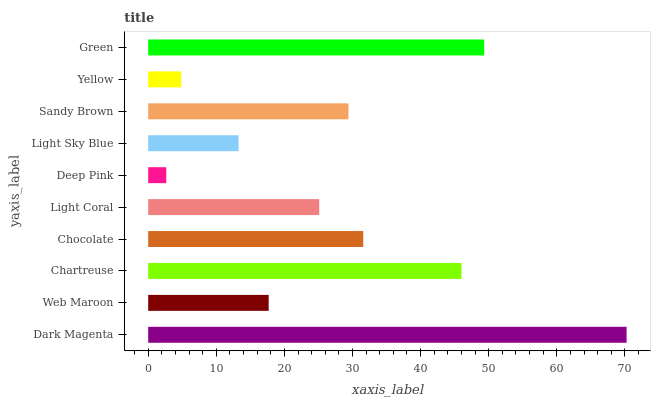Is Deep Pink the minimum?
Answer yes or no. Yes. Is Dark Magenta the maximum?
Answer yes or no. Yes. Is Web Maroon the minimum?
Answer yes or no. No. Is Web Maroon the maximum?
Answer yes or no. No. Is Dark Magenta greater than Web Maroon?
Answer yes or no. Yes. Is Web Maroon less than Dark Magenta?
Answer yes or no. Yes. Is Web Maroon greater than Dark Magenta?
Answer yes or no. No. Is Dark Magenta less than Web Maroon?
Answer yes or no. No. Is Sandy Brown the high median?
Answer yes or no. Yes. Is Light Coral the low median?
Answer yes or no. Yes. Is Light Sky Blue the high median?
Answer yes or no. No. Is Deep Pink the low median?
Answer yes or no. No. 